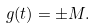Convert formula to latex. <formula><loc_0><loc_0><loc_500><loc_500>g ( t ) = \pm M .</formula> 